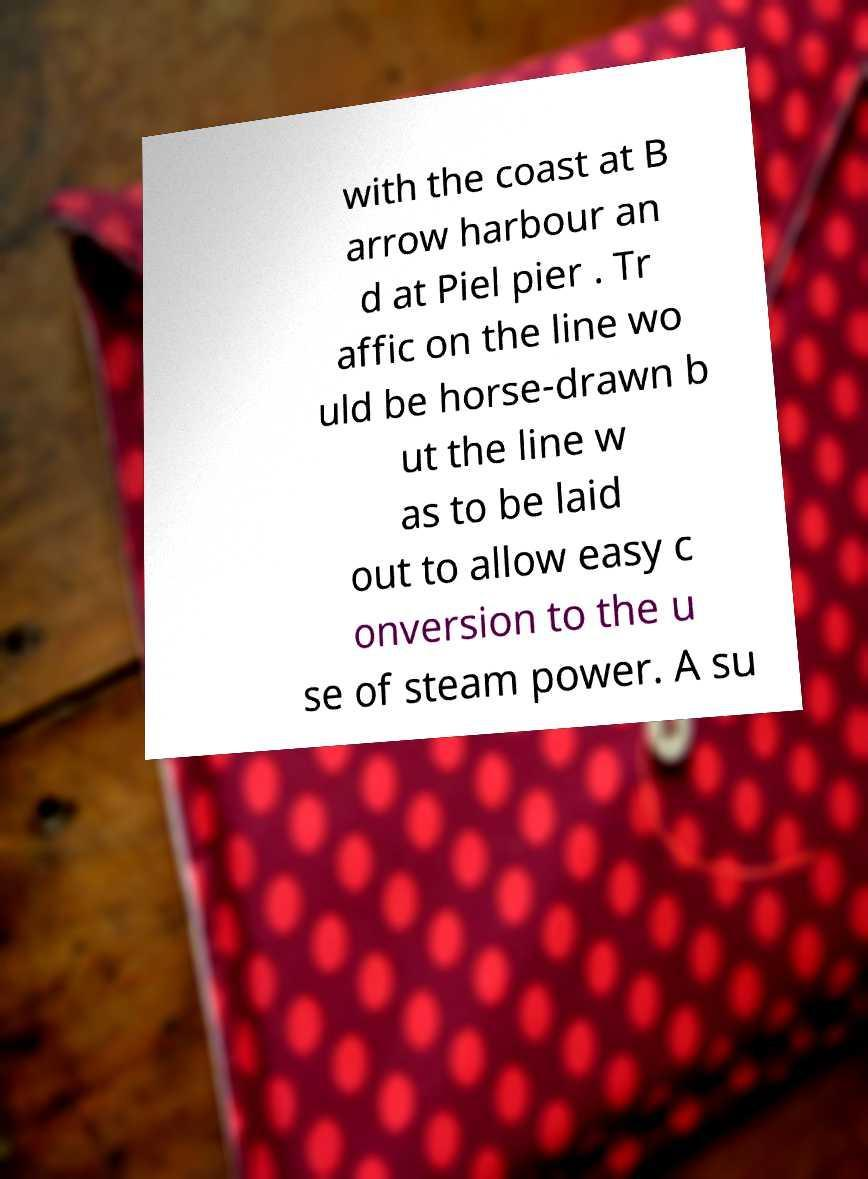Please read and relay the text visible in this image. What does it say? with the coast at B arrow harbour an d at Piel pier . Tr affic on the line wo uld be horse-drawn b ut the line w as to be laid out to allow easy c onversion to the u se of steam power. A su 